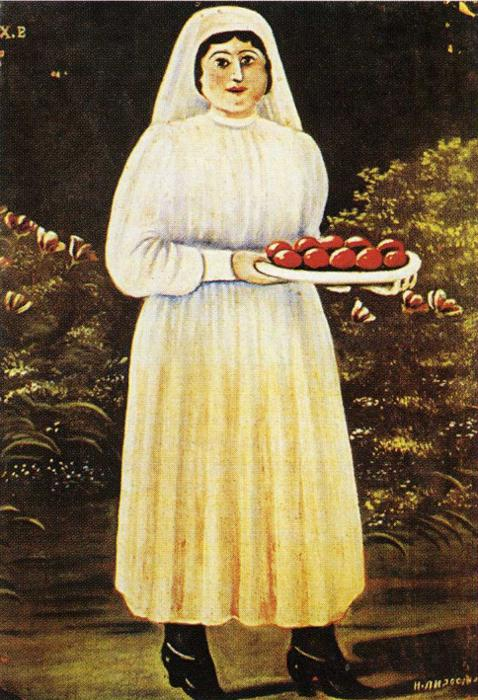How might this image be interpreted in a modern context? In a modern context, this image might be seen as a nostalgic nod to simpler times and the enduring value of nature and tradition. The woman could symbolize the caretaker role that many strive to embody in contemporary sustainable practices. Her calm demeanor and the natural elements around her might resonate with an audience seeking tranquility and a return to more grounded, less hectic lifestyles. This painting could be interpreted as a call to preserve and honor the earth’s bounties and the traditions that connect us to it. 